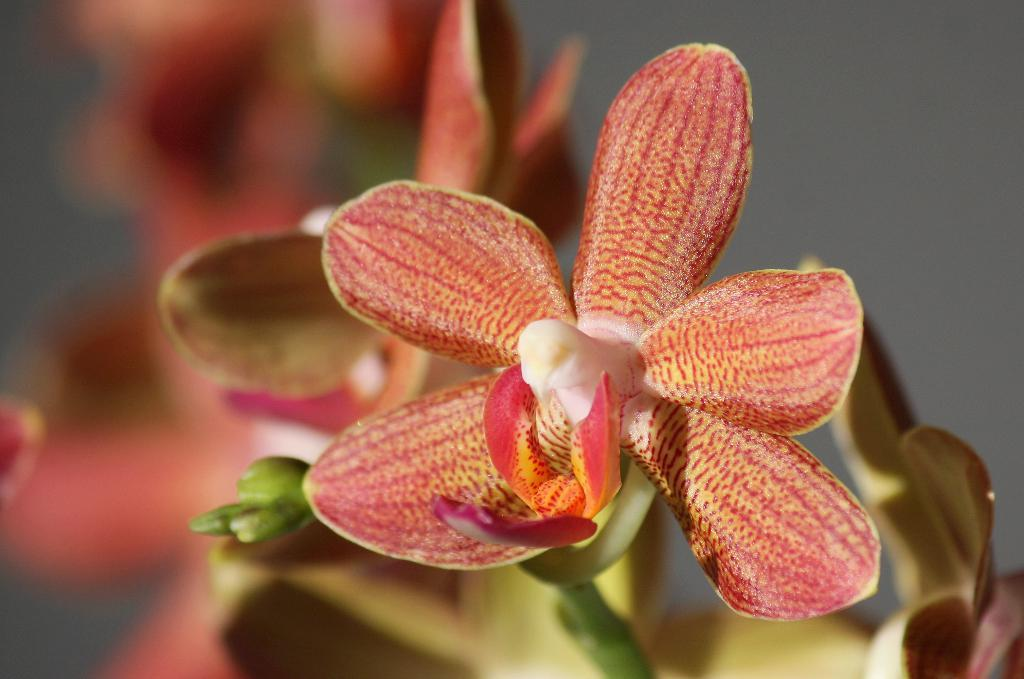What can be seen growing in the image? There is a flower on a plant in the image. Can you describe the background of the image? The background of the image is blurred. How many ladybugs are sitting on the flower in the image? There are no ladybugs present in the image; only the flower on a plant is visible. 